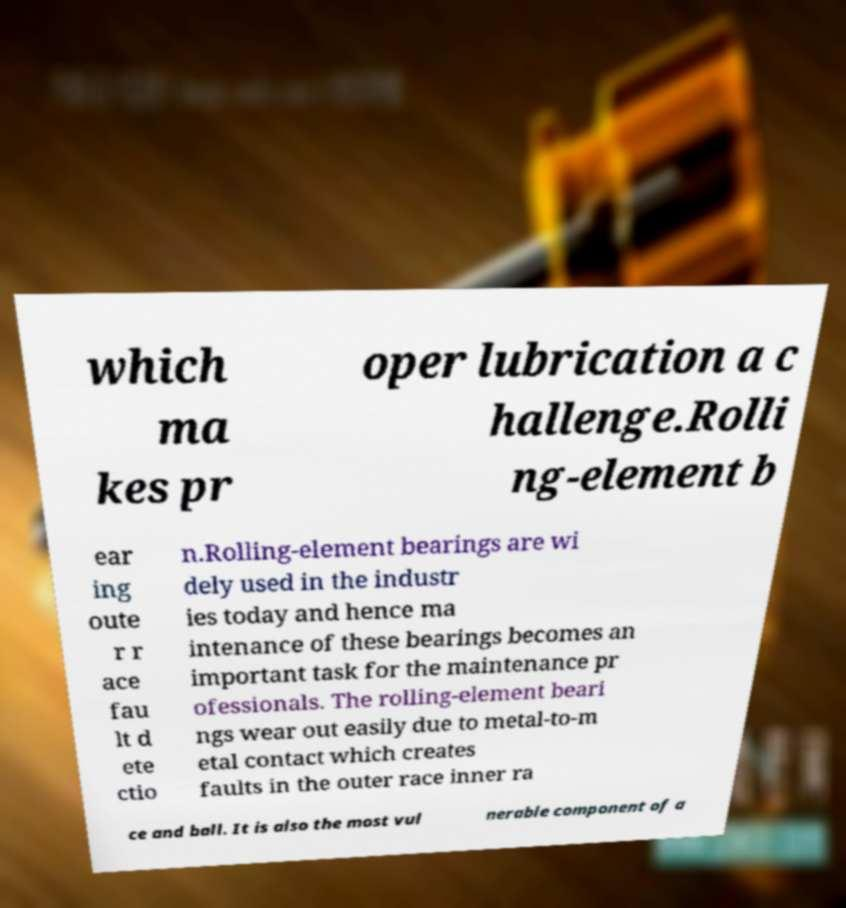Please identify and transcribe the text found in this image. which ma kes pr oper lubrication a c hallenge.Rolli ng-element b ear ing oute r r ace fau lt d ete ctio n.Rolling-element bearings are wi dely used in the industr ies today and hence ma intenance of these bearings becomes an important task for the maintenance pr ofessionals. The rolling-element beari ngs wear out easily due to metal-to-m etal contact which creates faults in the outer race inner ra ce and ball. It is also the most vul nerable component of a 